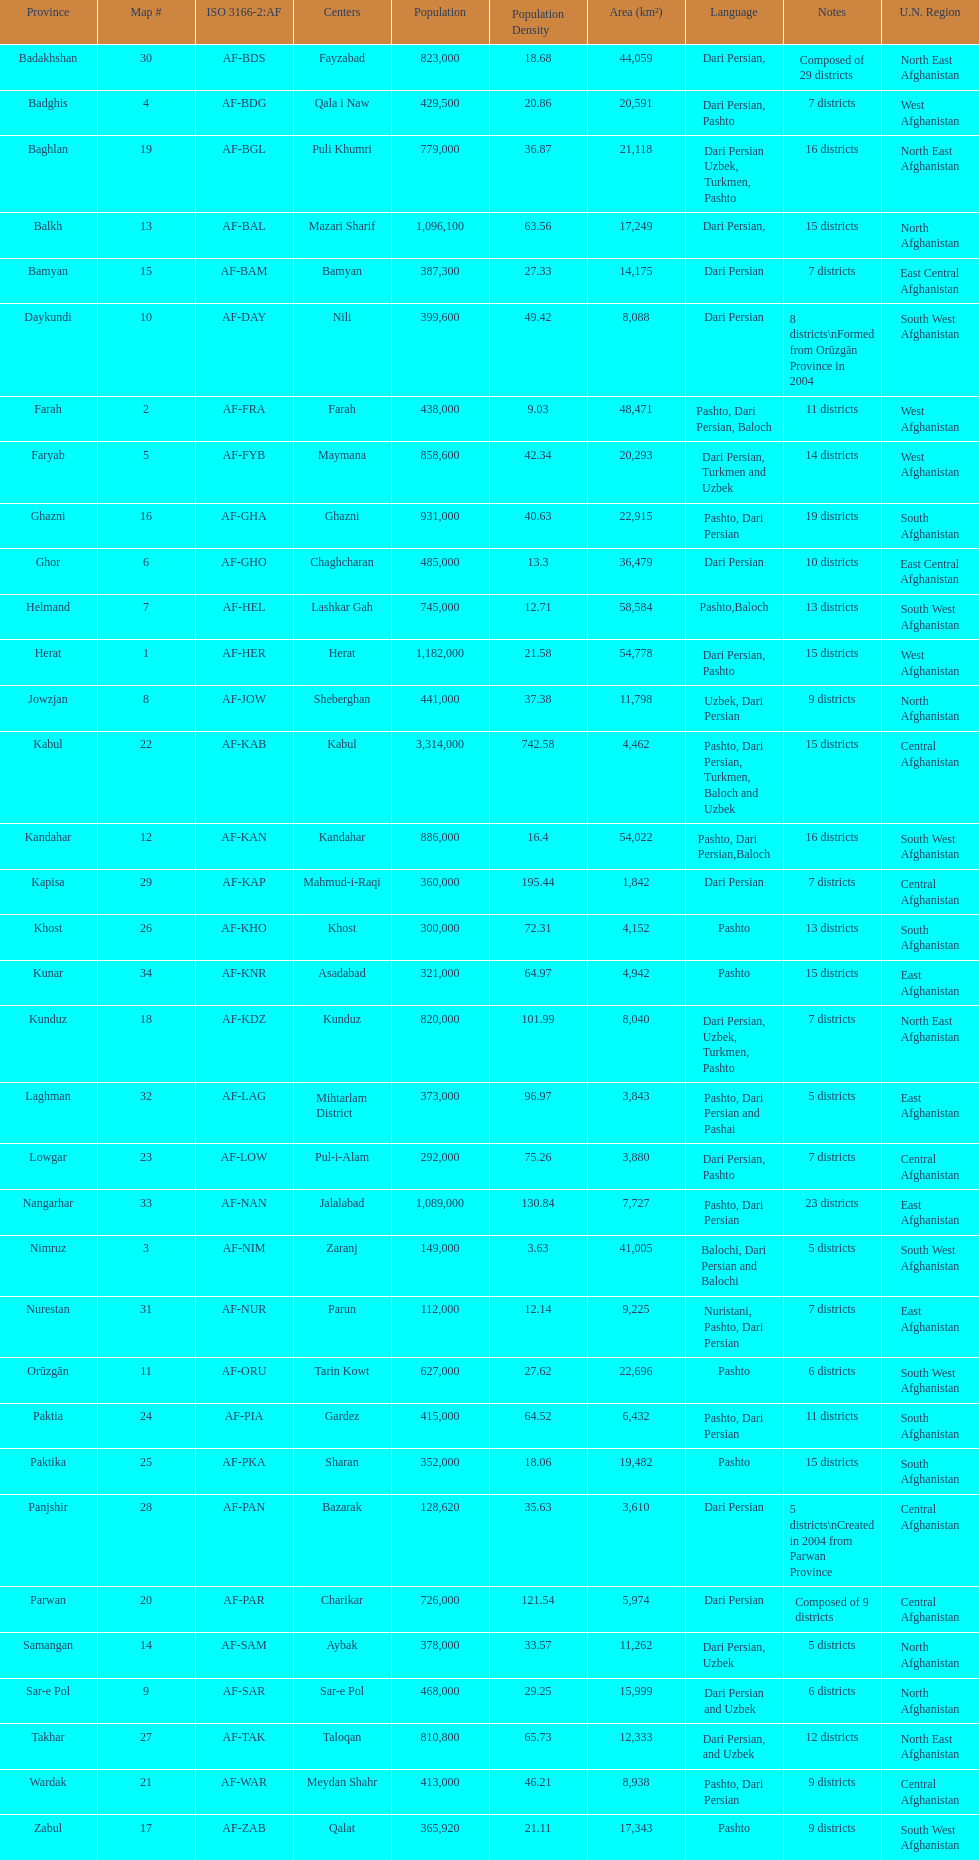What province is listed previous to ghor? Ghazni. 